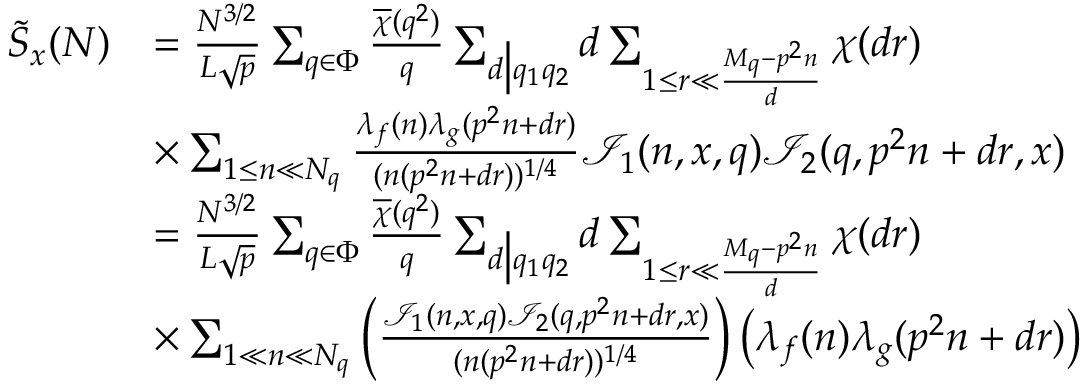Convert formula to latex. <formula><loc_0><loc_0><loc_500><loc_500>\begin{array} { r l } { \tilde { S } _ { x } ( N ) } & { = \frac { N ^ { 3 / 2 } } { L \sqrt { p } } \sum _ { q \in \Phi } \frac { \overline { \chi } ( q ^ { 2 } ) } { q } \sum _ { d \left | q _ { 1 } q _ { 2 } } d \sum _ { 1 \leq r \ll \frac { M _ { q } - p ^ { 2 } n } { d } } \chi ( d r ) } \\ & { \times \sum _ { 1 \leq n \ll N _ { q } } \frac { \lambda _ { f } ( n ) \lambda _ { g } ( p ^ { 2 } n + d r ) } { ( n ( p ^ { 2 } n + d r ) ) ^ { 1 / 4 } } \mathcal { I } _ { 1 } ( n , x , q ) \mathcal { I } _ { 2 } ( q , p ^ { 2 } n + d r , x ) } \\ & { = \frac { N ^ { 3 / 2 } } { L \sqrt { p } } \sum _ { q \in \Phi } \frac { \overline { \chi } ( q ^ { 2 } ) } { q } \sum _ { d \right | q _ { 1 } q _ { 2 } } d \sum _ { 1 \leq r \ll \frac { M _ { q } - p ^ { 2 } n } { d } } \chi ( d r ) } \\ & { \times \sum _ { 1 \ll n \ll N _ { q } } \left ( \frac { \mathcal { I } _ { 1 } ( n , x , q ) \mathcal { I } _ { 2 } ( q , p ^ { 2 } n + d r , x ) } { ( n ( p ^ { 2 } n + d r ) ) ^ { 1 / 4 } } \right ) \left ( \lambda _ { f } ( n ) \lambda _ { g } ( p ^ { 2 } n + d r ) \right ) } \end{array}</formula> 